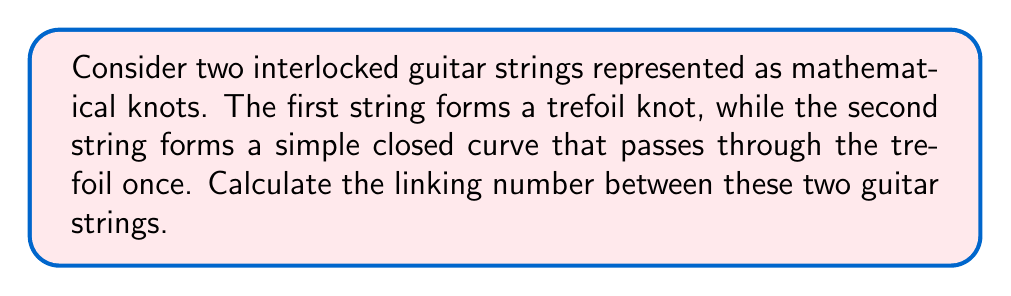Provide a solution to this math problem. To calculate the linking number between the two guitar strings, we'll follow these steps:

1. Understand the representation:
   - String 1: Trefoil knot
   - String 2: Simple closed curve passing through the trefoil once

2. Recall the definition of linking number:
   The linking number is half the sum of the signed crossings between the two curves in a regular projection.

3. Analyze the crossings:
   In a regular projection of this configuration, we'll have three crossings where the simple closed curve passes through the trefoil knot.

4. Determine the sign of each crossing:
   - For a right-handed trefoil knot, all three crossings will have the same sign.
   - Let's assume a right-handed trefoil for this example.
   - Each crossing will contribute +1 to the sum.

5. Calculate the sum of signed crossings:
   $\text{Sum} = (+1) + (+1) + (+1) = +3$

6. Apply the linking number formula:
   $$\text{Linking Number} = \frac{1}{2} \cdot \text{Sum of signed crossings}$$
   $$\text{Linking Number} = \frac{1}{2} \cdot (+3) = +\frac{3}{2}$$

The positive sign indicates that the curves are linked in a right-handed manner, which is consistent with our assumption of a right-handed trefoil knot.
Answer: $+\frac{3}{2}$ 